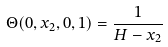<formula> <loc_0><loc_0><loc_500><loc_500>\Theta ( 0 , x _ { 2 } , 0 , 1 ) = \frac { 1 } { H - x _ { 2 } }</formula> 